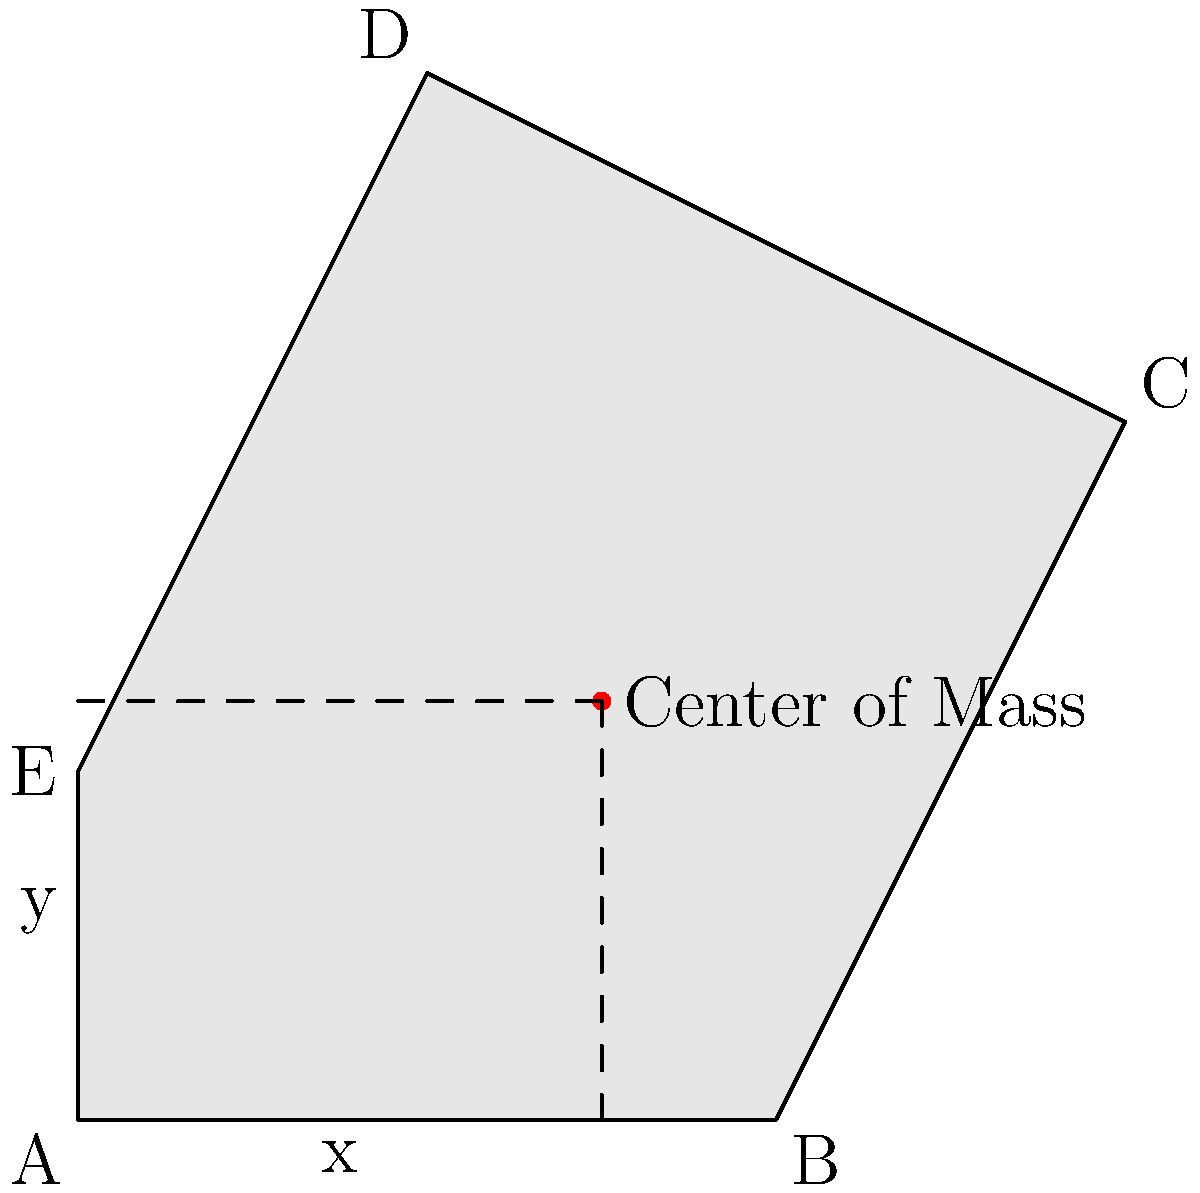As a web developer familiar with error handling, imagine you're creating a custom error logging system that visualizes error distributions across different components of your web application. The error occurrences form an irregular shape similar to the one shown in the diagram. To effectively represent this data, you need to find the center of mass of this shape. Given the coordinates of the vertices A(0,0), B(2,0), C(3,2), D(1,3), and E(0,1), calculate the x and y coordinates of the center of mass. To find the center of mass of an irregularly shaped object, we can follow these steps:

1. Divide the shape into triangles:
   Triangle 1: ABC
   Triangle 2: ACD
   Triangle 3: ADE

2. Calculate the area of each triangle using the formula:
   $A = \frac{1}{2}|x_1(y_2 - y_3) + x_2(y_3 - y_1) + x_3(y_1 - y_2)|$

   Triangle 1: $A_1 = \frac{1}{2}|0(0-2) + 2(2-0) + 3(0-0)| = 2$
   Triangle 2: $A_2 = \frac{1}{2}|0(3-2) + 1(2-0) + 3(0-3)| = 2.5$
   Triangle 3: $A_3 = \frac{1}{2}|0(3-1) + 1(1-0) + 0(0-3)| = 1$

3. Calculate the centroid of each triangle:
   $x_c = \frac{x_1 + x_2 + x_3}{3}, y_c = \frac{y_1 + y_2 + y_3}{3}$

   Triangle 1: $(x_{c1}, y_{c1}) = (\frac{0+2+3}{3}, \frac{0+0+2}{3}) = (\frac{5}{3}, \frac{2}{3})$
   Triangle 2: $(x_{c2}, y_{c2}) = (\frac{0+1+3}{3}, \frac{0+3+2}{3}) = (\frac{4}{3}, \frac{5}{3})$
   Triangle 3: $(x_{c3}, y_{c3}) = (\frac{0+1+0}{3}, \frac{0+3+1}{3}) = (\frac{1}{3}, \frac{4}{3})$

4. Calculate the total area:
   $A_{total} = A_1 + A_2 + A_3 = 2 + 2.5 + 1 = 5.5$

5. Calculate the center of mass using the weighted average:
   $x_{cm} = \frac{A_1x_{c1} + A_2x_{c2} + A_3x_{c3}}{A_{total}}$
   $y_{cm} = \frac{A_1y_{c1} + A_2y_{c2} + A_3y_{c3}}{A_{total}}$

   $x_{cm} = \frac{2(\frac{5}{3}) + 2.5(\frac{4}{3}) + 1(\frac{1}{3})}{5.5} = \frac{8.3333}{5.5} \approx 1.5152$

   $y_{cm} = \frac{2(\frac{2}{3}) + 2.5(\frac{5}{3}) + 1(\frac{4}{3})}{5.5} = \frac{6.6667}{5.5} \approx 1.2121$

Therefore, the center of mass is approximately at (1.5152, 1.2121).
Answer: (1.5152, 1.2121) 